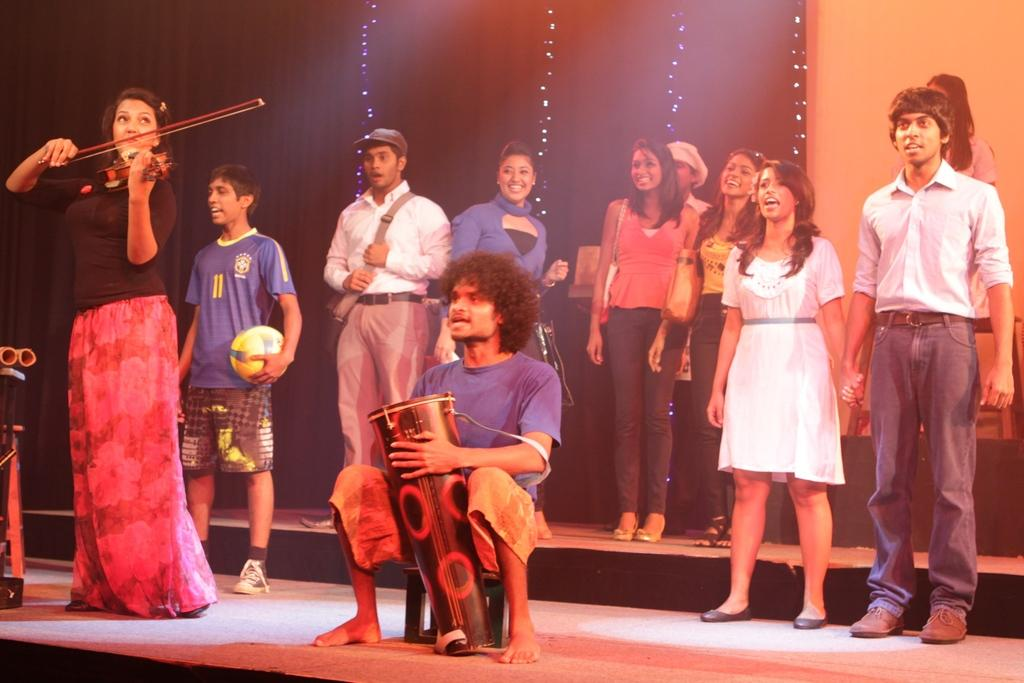What is happening on the stage in the image? There is a group of people on the stage. What type of objects can be seen with the group of people? Musical instruments are present in the image. What can be seen in the background of the stage? There is a wall and decorative lights visible in the background of the image. What type of leather is being used to make the rifle in the image? There is no rifle present in the image, so it is not possible to determine the type of leather being used. 